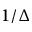<formula> <loc_0><loc_0><loc_500><loc_500>1 / \Delta</formula> 